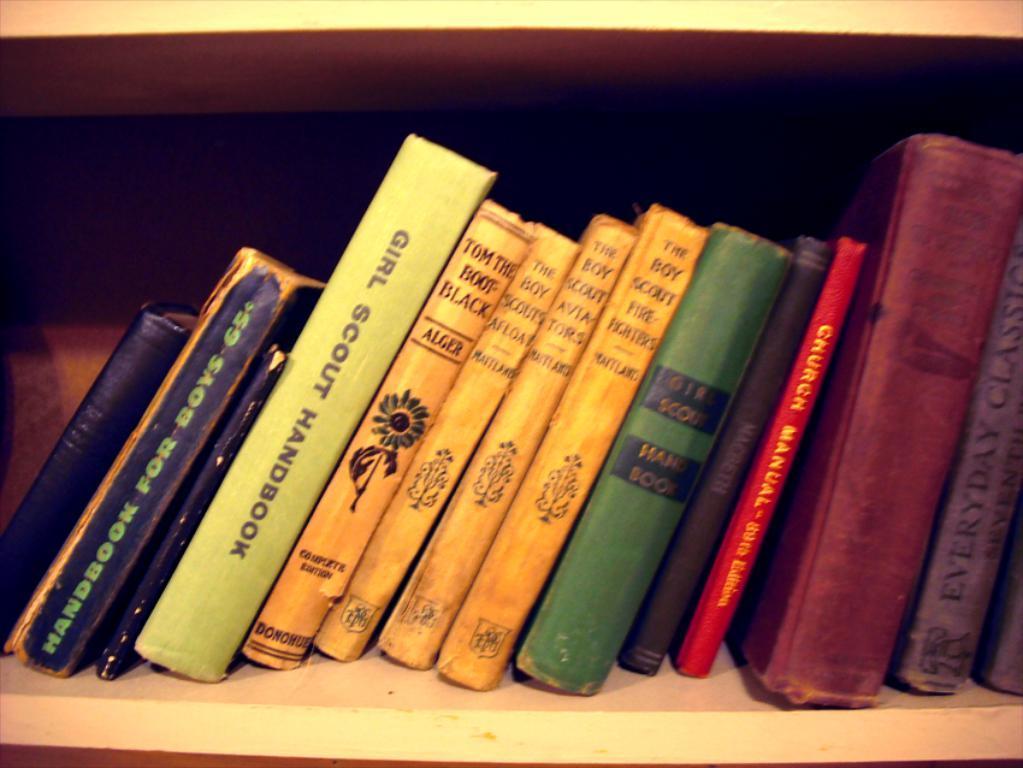Can you describe this image briefly? In this image we can see some books are arranged in a rack. 